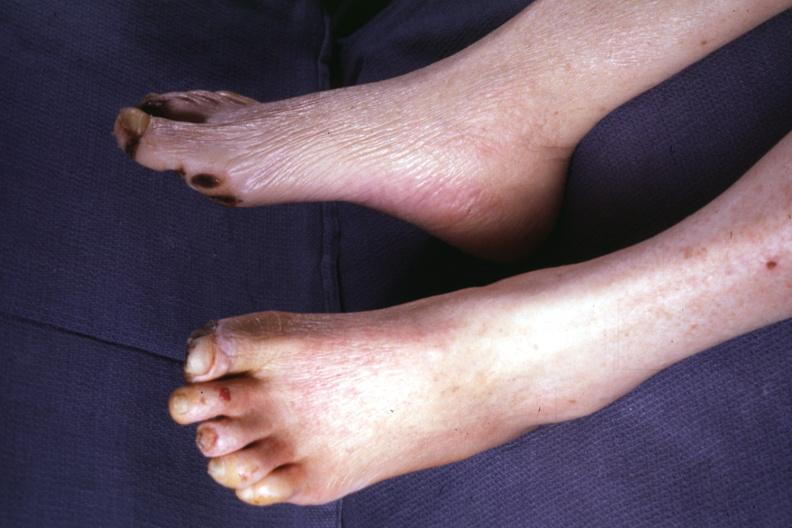does retroperitoneum show typical gangrene?
Answer the question using a single word or phrase. No 